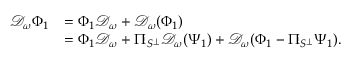Convert formula to latex. <formula><loc_0><loc_0><loc_500><loc_500>\begin{array} { r l } { \mathcal { D } _ { \omega } \Phi _ { 1 } } & { = \Phi _ { 1 } \mathcal { D } _ { \omega } + \mathcal { D } _ { \omega } ( \Phi _ { 1 } ) } \\ & { = \Phi _ { 1 } \mathcal { D } _ { \omega } + \Pi _ { S ^ { \perp } } \mathcal { D } _ { \omega } ( \Psi _ { 1 } ) + \mathcal { D } _ { \omega } ( \Phi _ { 1 } - \Pi _ { S ^ { \perp } } \Psi _ { 1 } ) . } \end{array}</formula> 